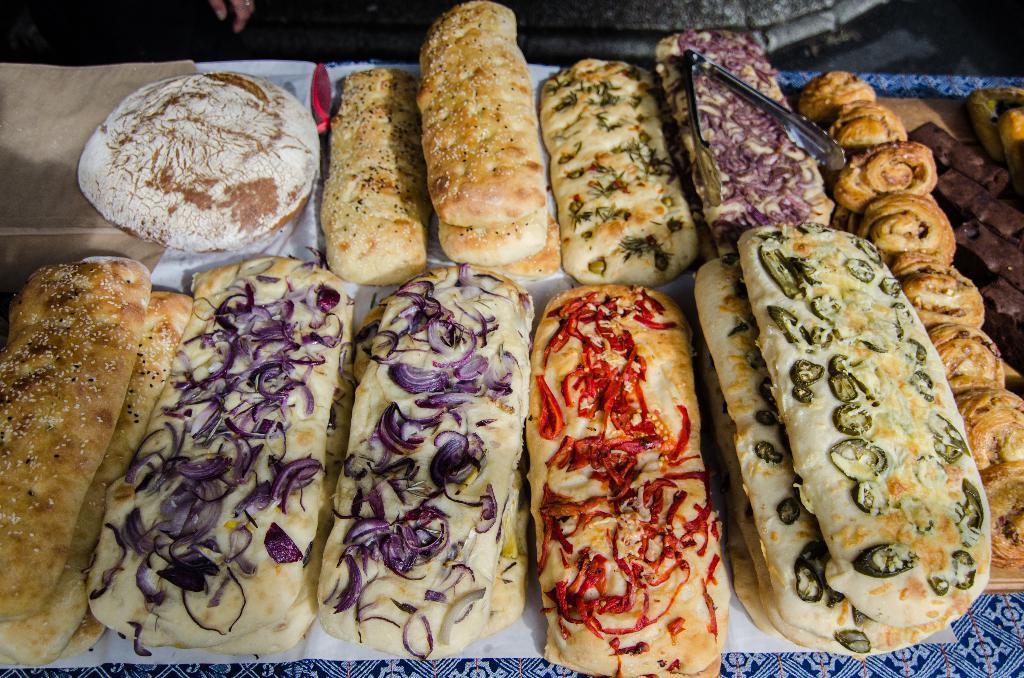In one or two sentences, can you explain what this image depicts? In this picture we can see a table. On the table we can see the papers, food items and holder. At the top of the image we can see the floor and person's hand. 